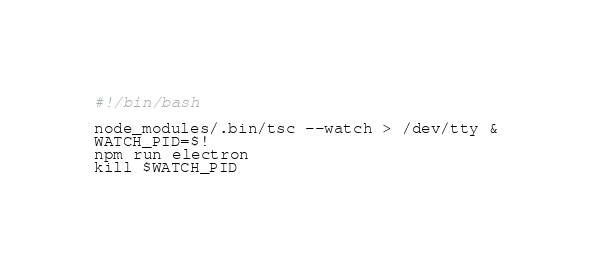<code> <loc_0><loc_0><loc_500><loc_500><_Bash_>#!/bin/bash

node_modules/.bin/tsc --watch > /dev/tty &
WATCH_PID=$!
npm run electron
kill $WATCH_PID
</code> 